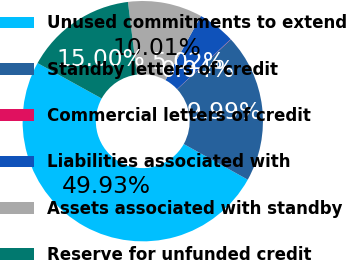<chart> <loc_0><loc_0><loc_500><loc_500><pie_chart><fcel>Unused commitments to extend<fcel>Standby letters of credit<fcel>Commercial letters of credit<fcel>Liabilities associated with<fcel>Assets associated with standby<fcel>Reserve for unfunded credit<nl><fcel>49.93%<fcel>19.99%<fcel>0.04%<fcel>5.02%<fcel>10.01%<fcel>15.0%<nl></chart> 